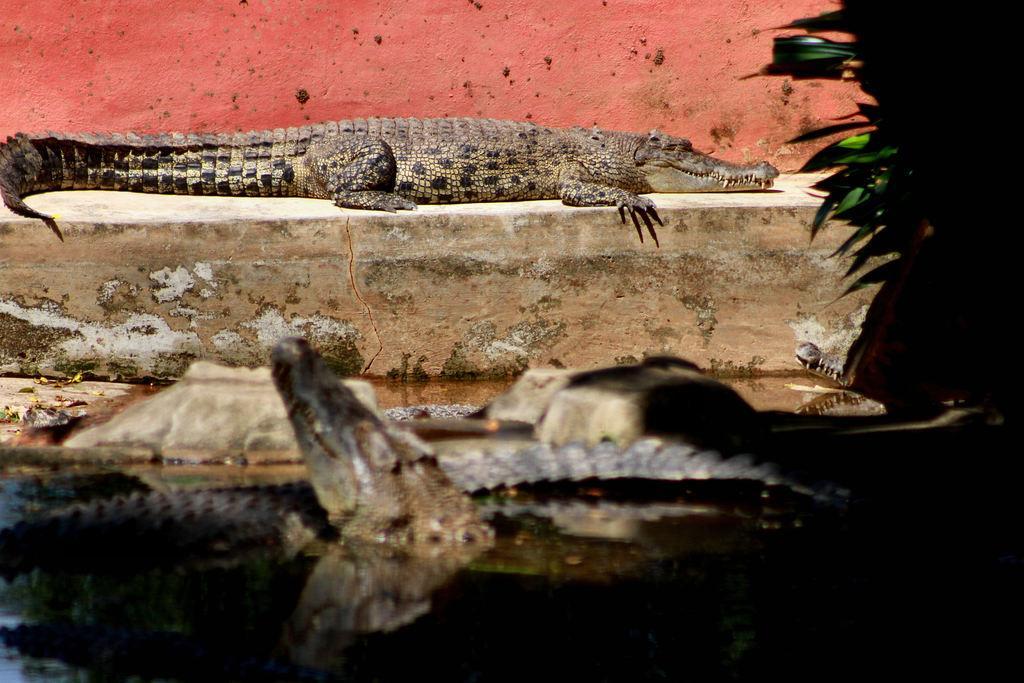How would you summarize this image in a sentence or two? In this image at the bottom there is one pond, and in the pond there is one crocodile and sand and some rocks. And in the background there is wall, on the wall there is another crocodile and on the right side of the image there are some plants and in the background there is wall. 